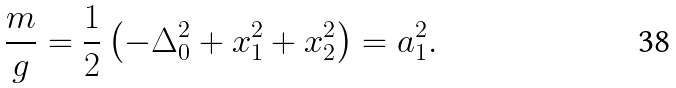Convert formula to latex. <formula><loc_0><loc_0><loc_500><loc_500>\frac { m } { g } = \frac { 1 } { 2 } \left ( - \Delta _ { 0 } ^ { 2 } + x _ { 1 } ^ { 2 } + x _ { 2 } ^ { 2 } \right ) = a _ { 1 } ^ { 2 } .</formula> 